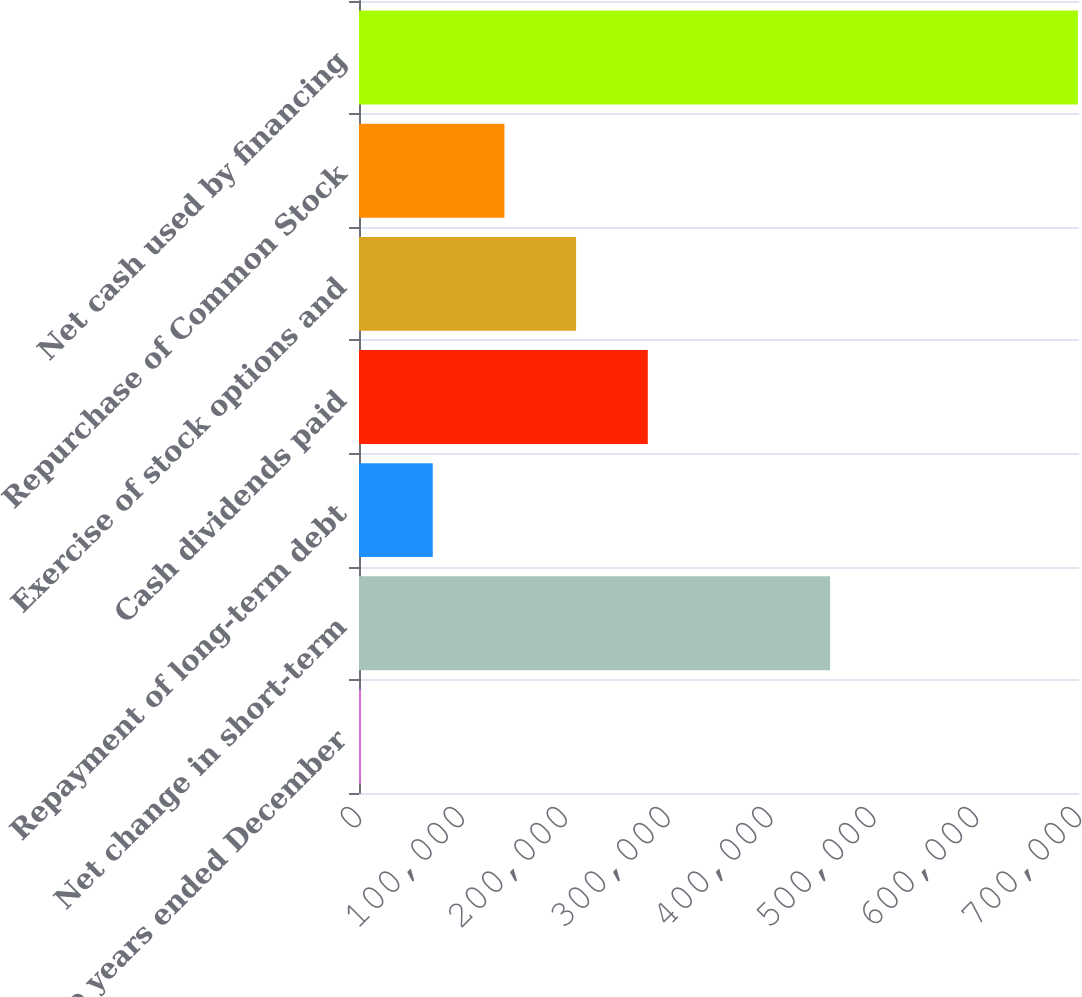Convert chart to OTSL. <chart><loc_0><loc_0><loc_500><loc_500><bar_chart><fcel>For the years ended December<fcel>Net change in short-term<fcel>Repayment of long-term debt<fcel>Cash dividends paid<fcel>Exercise of stock options and<fcel>Repurchase of Common Stock<fcel>Net cash used by financing<nl><fcel>2009<fcel>458047<fcel>71700.2<fcel>280774<fcel>211083<fcel>141391<fcel>698921<nl></chart> 